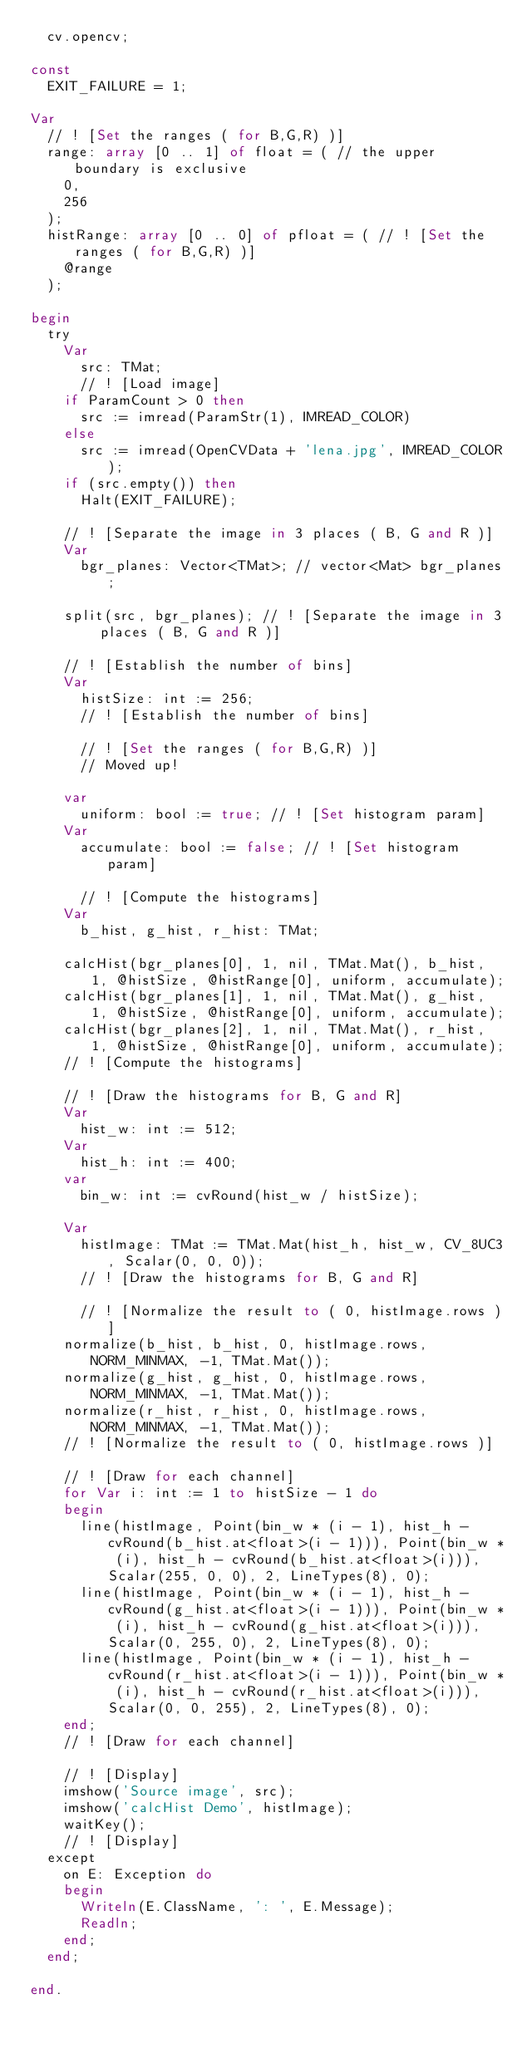Convert code to text. <code><loc_0><loc_0><loc_500><loc_500><_Pascal_>  cv.opencv;

const
  EXIT_FAILURE = 1;

Var
  // ! [Set the ranges ( for B,G,R) )]
  range: array [0 .. 1] of float = ( // the upper boundary is exclusive
    0,
    256
  );
  histRange: array [0 .. 0] of pfloat = ( // ! [Set the ranges ( for B,G,R) )]
    @range
  );

begin
  try
    Var
      src: TMat;
      // ! [Load image]
    if ParamCount > 0 then
      src := imread(ParamStr(1), IMREAD_COLOR)
    else
      src := imread(OpenCVData + 'lena.jpg', IMREAD_COLOR);
    if (src.empty()) then
      Halt(EXIT_FAILURE);

    // ! [Separate the image in 3 places ( B, G and R )]
    Var
      bgr_planes: Vector<TMat>; // vector<Mat> bgr_planes;

    split(src, bgr_planes); // ! [Separate the image in 3 places ( B, G and R )]

    // ! [Establish the number of bins]
    Var
      histSize: int := 256;
      // ! [Establish the number of bins]

      // ! [Set the ranges ( for B,G,R) )]
      // Moved up!

    var
      uniform: bool := true; // ! [Set histogram param]
    Var
      accumulate: bool := false; // ! [Set histogram param]

      // ! [Compute the histograms]
    Var
      b_hist, g_hist, r_hist: TMat;

    calcHist(bgr_planes[0], 1, nil, TMat.Mat(), b_hist, 1, @histSize, @histRange[0], uniform, accumulate);
    calcHist(bgr_planes[1], 1, nil, TMat.Mat(), g_hist, 1, @histSize, @histRange[0], uniform, accumulate);
    calcHist(bgr_planes[2], 1, nil, TMat.Mat(), r_hist, 1, @histSize, @histRange[0], uniform, accumulate);
    // ! [Compute the histograms]

    // ! [Draw the histograms for B, G and R]
    Var
      hist_w: int := 512;
    Var
      hist_h: int := 400;
    var
      bin_w: int := cvRound(hist_w / histSize);

    Var
      histImage: TMat := TMat.Mat(hist_h, hist_w, CV_8UC3, Scalar(0, 0, 0));
      // ! [Draw the histograms for B, G and R]

      // ! [Normalize the result to ( 0, histImage.rows )]
    normalize(b_hist, b_hist, 0, histImage.rows, NORM_MINMAX, -1, TMat.Mat());
    normalize(g_hist, g_hist, 0, histImage.rows, NORM_MINMAX, -1, TMat.Mat());
    normalize(r_hist, r_hist, 0, histImage.rows, NORM_MINMAX, -1, TMat.Mat());
    // ! [Normalize the result to ( 0, histImage.rows )]

    // ! [Draw for each channel]
    for Var i: int := 1 to histSize - 1 do
    begin
      line(histImage, Point(bin_w * (i - 1), hist_h - cvRound(b_hist.at<float>(i - 1))), Point(bin_w * (i), hist_h - cvRound(b_hist.at<float>(i))), Scalar(255, 0, 0), 2, LineTypes(8), 0);
      line(histImage, Point(bin_w * (i - 1), hist_h - cvRound(g_hist.at<float>(i - 1))), Point(bin_w * (i), hist_h - cvRound(g_hist.at<float>(i))), Scalar(0, 255, 0), 2, LineTypes(8), 0);
      line(histImage, Point(bin_w * (i - 1), hist_h - cvRound(r_hist.at<float>(i - 1))), Point(bin_w * (i), hist_h - cvRound(r_hist.at<float>(i))), Scalar(0, 0, 255), 2, LineTypes(8), 0);
    end;
    // ! [Draw for each channel]

    // ! [Display]
    imshow('Source image', src);
    imshow('calcHist Demo', histImage);
    waitKey();
    // ! [Display]
  except
    on E: Exception do
    begin
      Writeln(E.ClassName, ': ', E.Message);
      Readln;
    end;
  end;

end.
</code> 